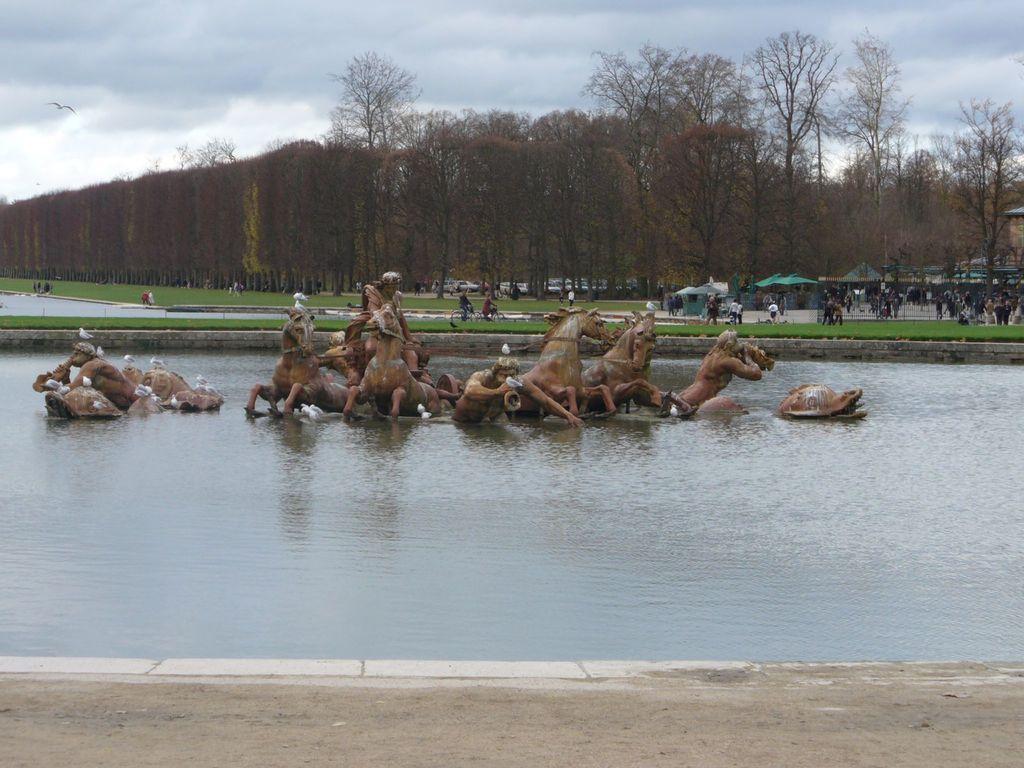How would you summarize this image in a sentence or two? In this image we can see the statues of horses and also the people. We can also see the water, path, grass and also the trees. In the background we can see the tents for shelter. We can also see the people. We can see a bird flying. There is a cloudy sky. 